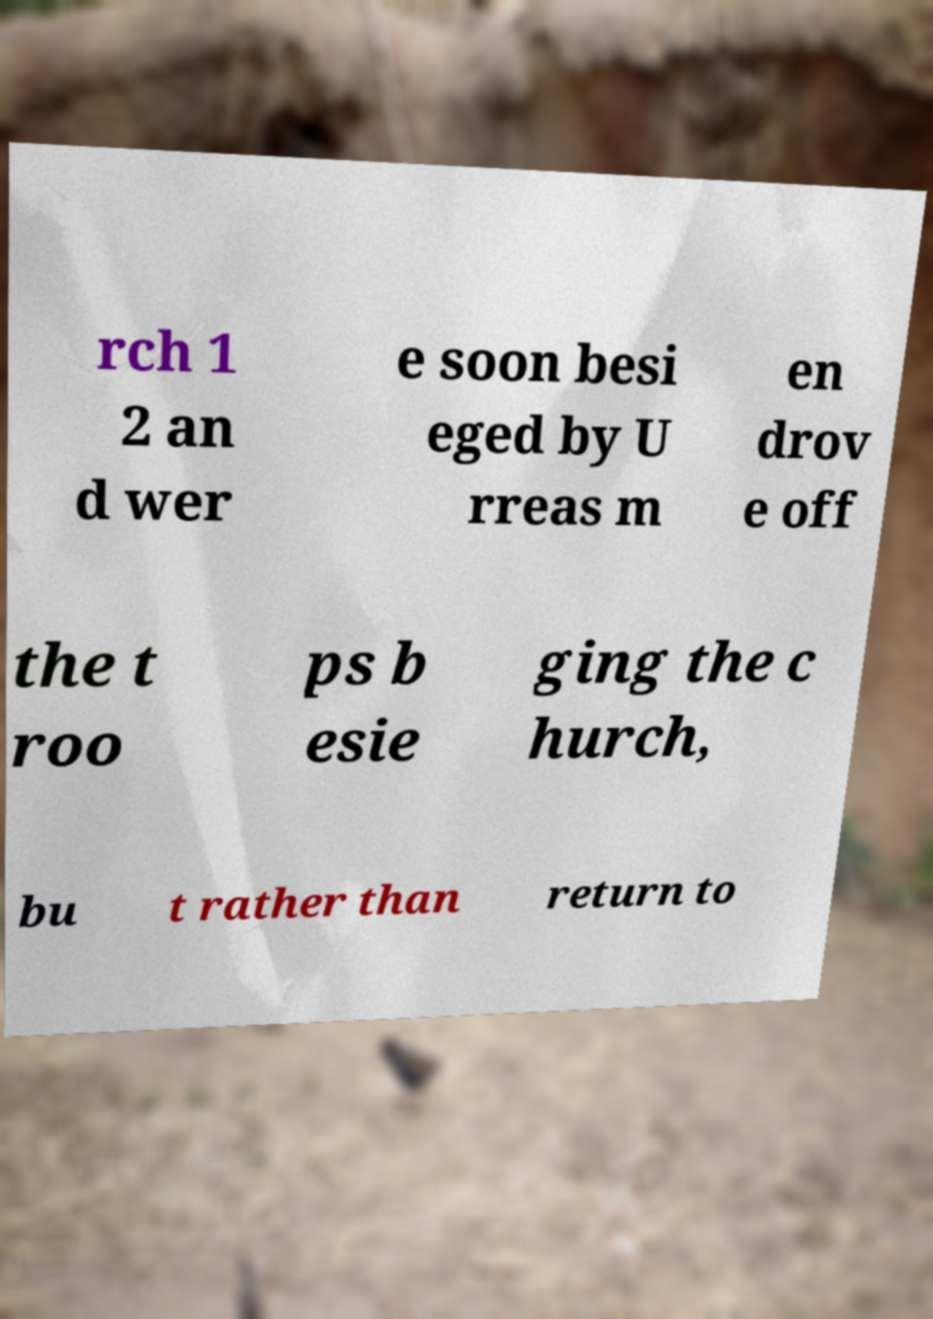For documentation purposes, I need the text within this image transcribed. Could you provide that? rch 1 2 an d wer e soon besi eged by U rreas m en drov e off the t roo ps b esie ging the c hurch, bu t rather than return to 